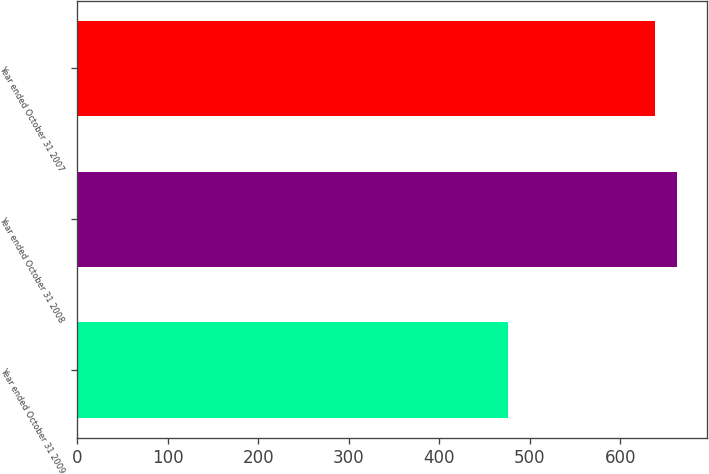Convert chart to OTSL. <chart><loc_0><loc_0><loc_500><loc_500><bar_chart><fcel>Year ended October 31 2009<fcel>Year ended October 31 2008<fcel>Year ended October 31 2007<nl><fcel>476<fcel>663<fcel>638<nl></chart> 